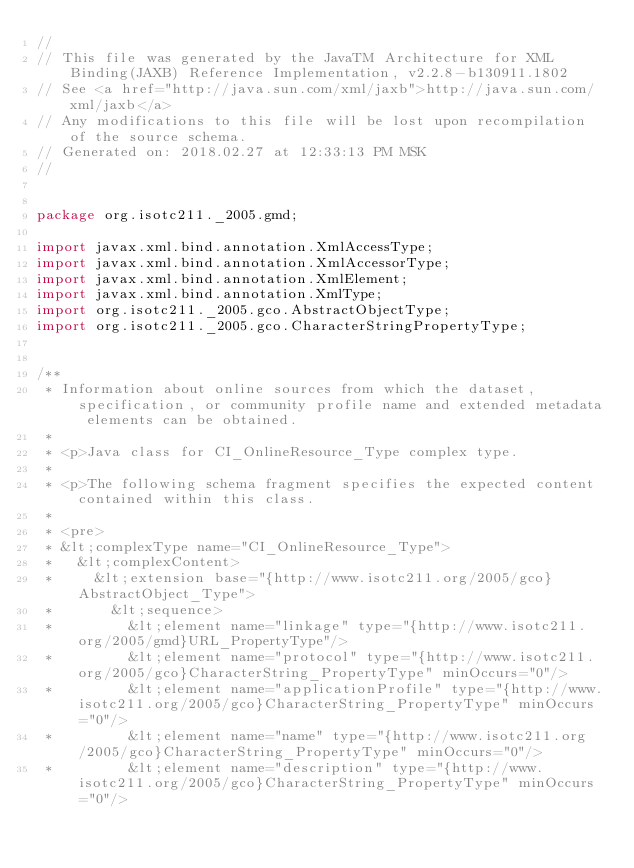<code> <loc_0><loc_0><loc_500><loc_500><_Java_>//
// This file was generated by the JavaTM Architecture for XML Binding(JAXB) Reference Implementation, v2.2.8-b130911.1802 
// See <a href="http://java.sun.com/xml/jaxb">http://java.sun.com/xml/jaxb</a> 
// Any modifications to this file will be lost upon recompilation of the source schema. 
// Generated on: 2018.02.27 at 12:33:13 PM MSK 
//


package org.isotc211._2005.gmd;

import javax.xml.bind.annotation.XmlAccessType;
import javax.xml.bind.annotation.XmlAccessorType;
import javax.xml.bind.annotation.XmlElement;
import javax.xml.bind.annotation.XmlType;
import org.isotc211._2005.gco.AbstractObjectType;
import org.isotc211._2005.gco.CharacterStringPropertyType;


/**
 * Information about online sources from which the dataset, specification, or community profile name and extended metadata elements can be obtained.
 * 
 * <p>Java class for CI_OnlineResource_Type complex type.
 * 
 * <p>The following schema fragment specifies the expected content contained within this class.
 * 
 * <pre>
 * &lt;complexType name="CI_OnlineResource_Type">
 *   &lt;complexContent>
 *     &lt;extension base="{http://www.isotc211.org/2005/gco}AbstractObject_Type">
 *       &lt;sequence>
 *         &lt;element name="linkage" type="{http://www.isotc211.org/2005/gmd}URL_PropertyType"/>
 *         &lt;element name="protocol" type="{http://www.isotc211.org/2005/gco}CharacterString_PropertyType" minOccurs="0"/>
 *         &lt;element name="applicationProfile" type="{http://www.isotc211.org/2005/gco}CharacterString_PropertyType" minOccurs="0"/>
 *         &lt;element name="name" type="{http://www.isotc211.org/2005/gco}CharacterString_PropertyType" minOccurs="0"/>
 *         &lt;element name="description" type="{http://www.isotc211.org/2005/gco}CharacterString_PropertyType" minOccurs="0"/></code> 